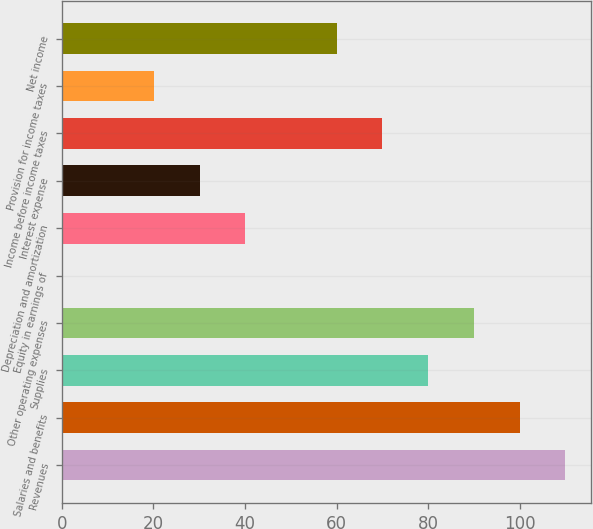Convert chart. <chart><loc_0><loc_0><loc_500><loc_500><bar_chart><fcel>Revenues<fcel>Salaries and benefits<fcel>Supplies<fcel>Other operating expenses<fcel>Equity in earnings of<fcel>Depreciation and amortization<fcel>Interest expense<fcel>Income before income taxes<fcel>Provision for income taxes<fcel>Net income<nl><fcel>109.99<fcel>100<fcel>80.02<fcel>90.01<fcel>0.1<fcel>40.06<fcel>30.07<fcel>70.03<fcel>20.08<fcel>60.04<nl></chart> 